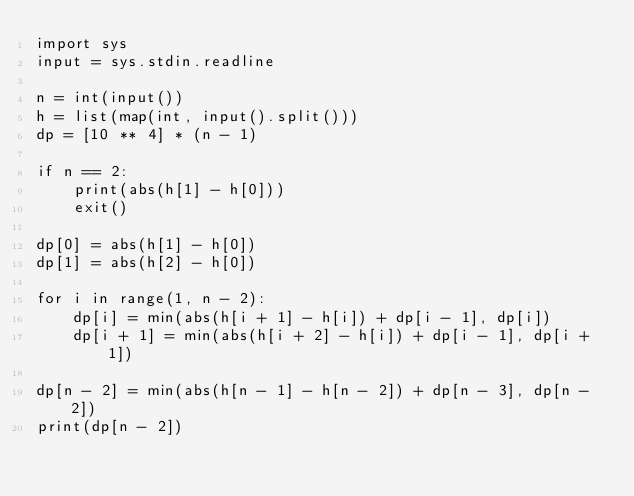Convert code to text. <code><loc_0><loc_0><loc_500><loc_500><_Python_>import sys
input = sys.stdin.readline

n = int(input())
h = list(map(int, input().split()))
dp = [10 ** 4] * (n - 1)

if n == 2:
    print(abs(h[1] - h[0]))
    exit()

dp[0] = abs(h[1] - h[0])
dp[1] = abs(h[2] - h[0])

for i in range(1, n - 2):
    dp[i] = min(abs(h[i + 1] - h[i]) + dp[i - 1], dp[i])
    dp[i + 1] = min(abs(h[i + 2] - h[i]) + dp[i - 1], dp[i + 1])

dp[n - 2] = min(abs(h[n - 1] - h[n - 2]) + dp[n - 3], dp[n - 2])
print(dp[n - 2])
</code> 